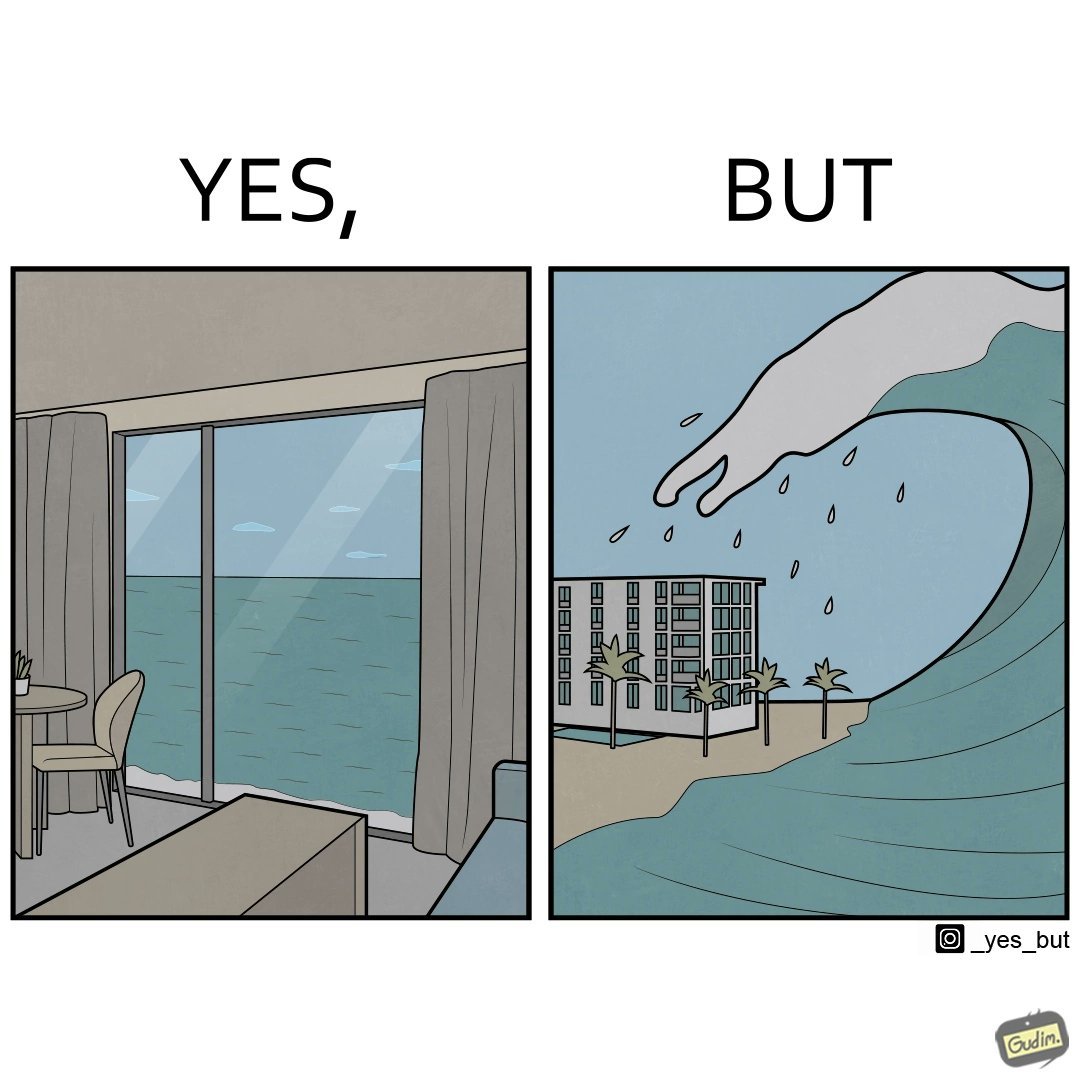Would you classify this image as satirical? Yes, this image is satirical. 